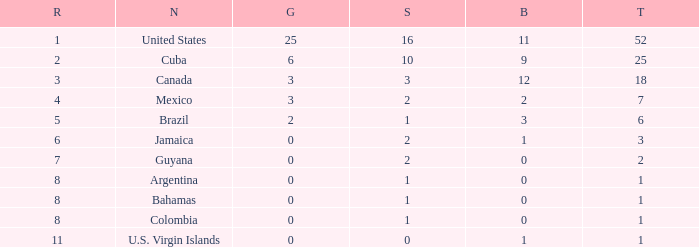What is the fewest number of silver medals a nation who ranked below 8 received? 0.0. 